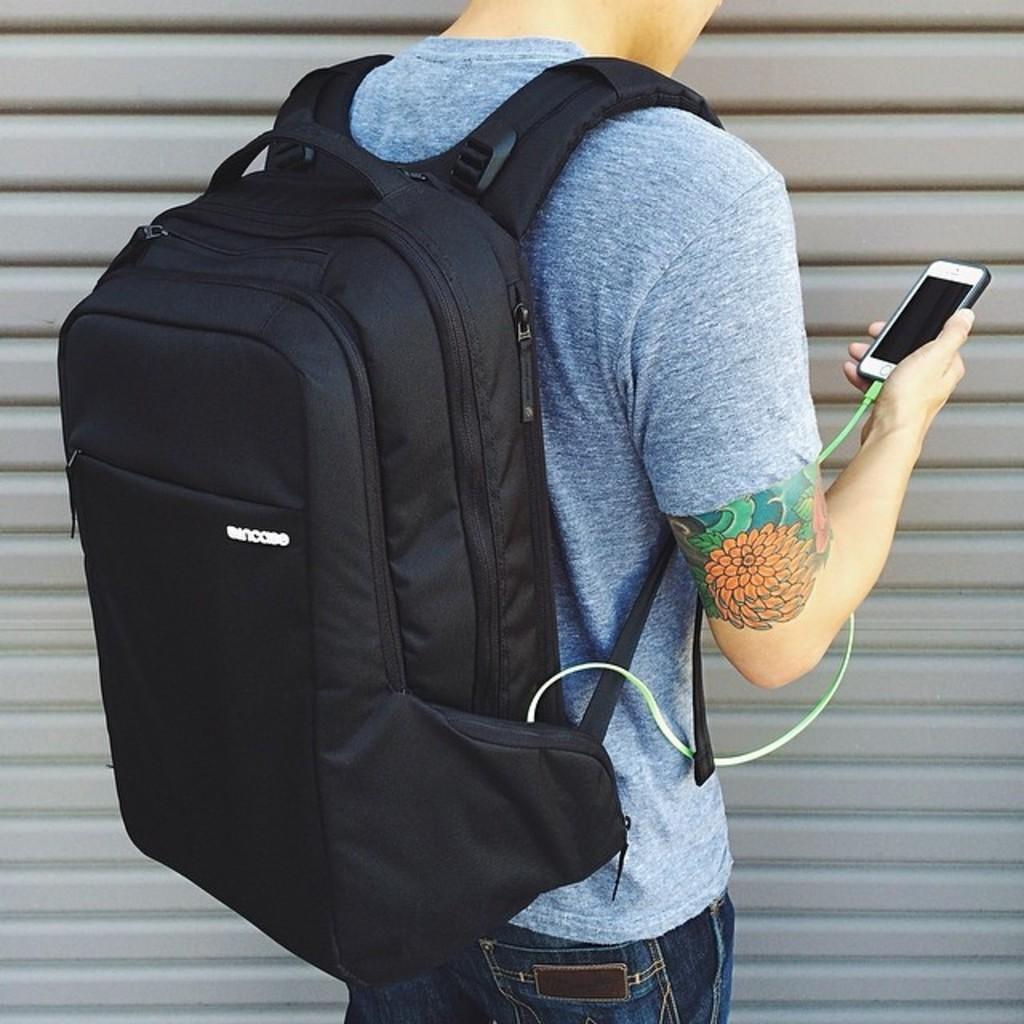What is the person in the image doing? The person in the image is carrying a bag. Can you describe the bag the person is carrying? The bag is black. What else is the person holding in his hand? The person is holding a phone in his hand. What is the person wearing on his upper body? The person is wearing a grey t-shirt. Are there any visible markings or designs on the person's body? Yes, the person has a tattoo on his hand. What type of butter is being used to invent a new hairstyle in the image? There is no butter or invention of a new hairstyle present in the image. 